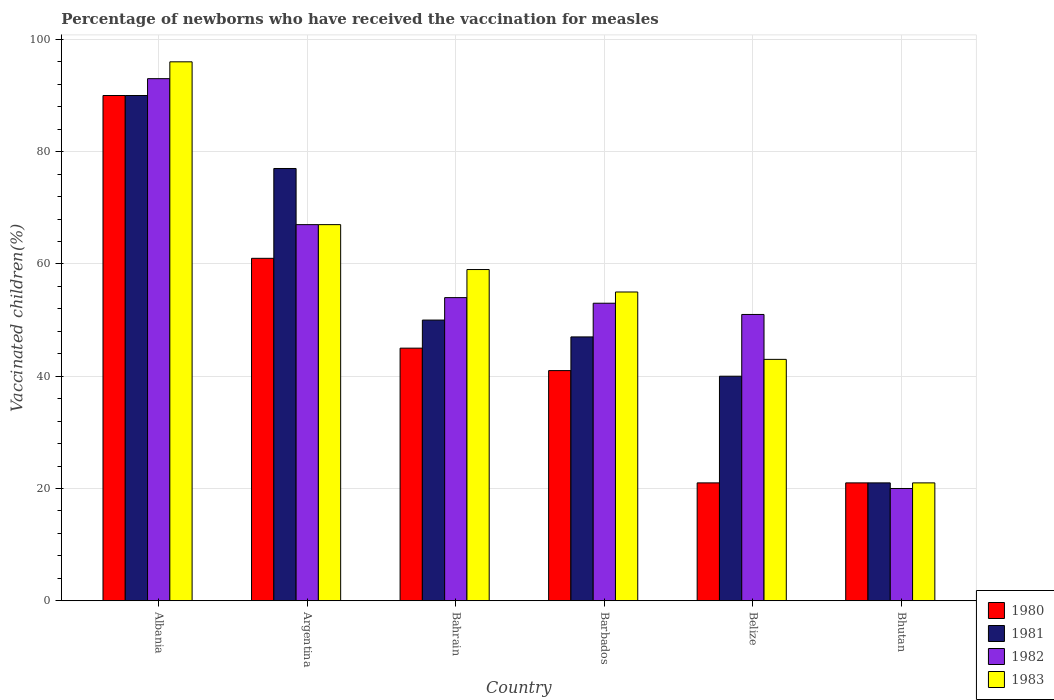Are the number of bars per tick equal to the number of legend labels?
Keep it short and to the point. Yes. What is the label of the 3rd group of bars from the left?
Offer a terse response. Bahrain. In how many cases, is the number of bars for a given country not equal to the number of legend labels?
Offer a terse response. 0. What is the percentage of vaccinated children in 1983 in Albania?
Offer a very short reply. 96. Across all countries, what is the maximum percentage of vaccinated children in 1983?
Make the answer very short. 96. In which country was the percentage of vaccinated children in 1981 maximum?
Provide a succinct answer. Albania. In which country was the percentage of vaccinated children in 1981 minimum?
Offer a terse response. Bhutan. What is the total percentage of vaccinated children in 1982 in the graph?
Your answer should be compact. 338. What is the difference between the percentage of vaccinated children in 1983 in Barbados and that in Belize?
Make the answer very short. 12. What is the average percentage of vaccinated children in 1982 per country?
Provide a short and direct response. 56.33. What is the ratio of the percentage of vaccinated children in 1981 in Argentina to that in Belize?
Your answer should be compact. 1.93. Is the percentage of vaccinated children in 1983 in Albania less than that in Bhutan?
Ensure brevity in your answer.  No. What is the difference between the highest and the lowest percentage of vaccinated children in 1981?
Make the answer very short. 69. Is the sum of the percentage of vaccinated children in 1983 in Albania and Barbados greater than the maximum percentage of vaccinated children in 1980 across all countries?
Your response must be concise. Yes. Is it the case that in every country, the sum of the percentage of vaccinated children in 1981 and percentage of vaccinated children in 1982 is greater than the sum of percentage of vaccinated children in 1983 and percentage of vaccinated children in 1980?
Give a very brief answer. No. Is it the case that in every country, the sum of the percentage of vaccinated children in 1980 and percentage of vaccinated children in 1981 is greater than the percentage of vaccinated children in 1983?
Provide a succinct answer. Yes. How many bars are there?
Your response must be concise. 24. How many countries are there in the graph?
Ensure brevity in your answer.  6. What is the difference between two consecutive major ticks on the Y-axis?
Keep it short and to the point. 20. Does the graph contain any zero values?
Give a very brief answer. No. Does the graph contain grids?
Make the answer very short. Yes. How are the legend labels stacked?
Provide a short and direct response. Vertical. What is the title of the graph?
Your response must be concise. Percentage of newborns who have received the vaccination for measles. What is the label or title of the X-axis?
Your answer should be very brief. Country. What is the label or title of the Y-axis?
Offer a very short reply. Vaccinated children(%). What is the Vaccinated children(%) of 1981 in Albania?
Ensure brevity in your answer.  90. What is the Vaccinated children(%) in 1982 in Albania?
Your response must be concise. 93. What is the Vaccinated children(%) of 1983 in Albania?
Give a very brief answer. 96. What is the Vaccinated children(%) of 1981 in Argentina?
Keep it short and to the point. 77. What is the Vaccinated children(%) of 1983 in Argentina?
Ensure brevity in your answer.  67. What is the Vaccinated children(%) of 1983 in Bahrain?
Give a very brief answer. 59. What is the Vaccinated children(%) in 1980 in Belize?
Your answer should be very brief. 21. What is the Vaccinated children(%) in 1982 in Belize?
Your answer should be compact. 51. What is the Vaccinated children(%) in 1981 in Bhutan?
Provide a short and direct response. 21. Across all countries, what is the maximum Vaccinated children(%) in 1980?
Ensure brevity in your answer.  90. Across all countries, what is the maximum Vaccinated children(%) in 1982?
Make the answer very short. 93. Across all countries, what is the maximum Vaccinated children(%) in 1983?
Your answer should be compact. 96. Across all countries, what is the minimum Vaccinated children(%) in 1981?
Offer a terse response. 21. Across all countries, what is the minimum Vaccinated children(%) of 1983?
Ensure brevity in your answer.  21. What is the total Vaccinated children(%) in 1980 in the graph?
Provide a succinct answer. 279. What is the total Vaccinated children(%) of 1981 in the graph?
Give a very brief answer. 325. What is the total Vaccinated children(%) of 1982 in the graph?
Make the answer very short. 338. What is the total Vaccinated children(%) of 1983 in the graph?
Your answer should be compact. 341. What is the difference between the Vaccinated children(%) in 1981 in Albania and that in Argentina?
Ensure brevity in your answer.  13. What is the difference between the Vaccinated children(%) in 1982 in Albania and that in Argentina?
Your answer should be compact. 26. What is the difference between the Vaccinated children(%) in 1980 in Albania and that in Bahrain?
Provide a short and direct response. 45. What is the difference between the Vaccinated children(%) in 1981 in Albania and that in Bahrain?
Ensure brevity in your answer.  40. What is the difference between the Vaccinated children(%) in 1982 in Albania and that in Bahrain?
Keep it short and to the point. 39. What is the difference between the Vaccinated children(%) in 1980 in Albania and that in Barbados?
Provide a short and direct response. 49. What is the difference between the Vaccinated children(%) in 1982 in Albania and that in Barbados?
Give a very brief answer. 40. What is the difference between the Vaccinated children(%) in 1983 in Albania and that in Barbados?
Ensure brevity in your answer.  41. What is the difference between the Vaccinated children(%) in 1981 in Albania and that in Belize?
Keep it short and to the point. 50. What is the difference between the Vaccinated children(%) in 1983 in Albania and that in Belize?
Ensure brevity in your answer.  53. What is the difference between the Vaccinated children(%) of 1982 in Albania and that in Bhutan?
Provide a succinct answer. 73. What is the difference between the Vaccinated children(%) of 1983 in Albania and that in Bhutan?
Offer a very short reply. 75. What is the difference between the Vaccinated children(%) of 1982 in Argentina and that in Bahrain?
Your response must be concise. 13. What is the difference between the Vaccinated children(%) in 1983 in Argentina and that in Bahrain?
Provide a succinct answer. 8. What is the difference between the Vaccinated children(%) of 1980 in Argentina and that in Barbados?
Offer a very short reply. 20. What is the difference between the Vaccinated children(%) in 1981 in Argentina and that in Barbados?
Offer a terse response. 30. What is the difference between the Vaccinated children(%) in 1980 in Argentina and that in Bhutan?
Ensure brevity in your answer.  40. What is the difference between the Vaccinated children(%) in 1981 in Bahrain and that in Barbados?
Make the answer very short. 3. What is the difference between the Vaccinated children(%) of 1980 in Bahrain and that in Belize?
Your answer should be compact. 24. What is the difference between the Vaccinated children(%) in 1981 in Bahrain and that in Bhutan?
Ensure brevity in your answer.  29. What is the difference between the Vaccinated children(%) in 1981 in Barbados and that in Bhutan?
Your response must be concise. 26. What is the difference between the Vaccinated children(%) in 1983 in Barbados and that in Bhutan?
Your answer should be very brief. 34. What is the difference between the Vaccinated children(%) of 1980 in Belize and that in Bhutan?
Offer a very short reply. 0. What is the difference between the Vaccinated children(%) in 1982 in Belize and that in Bhutan?
Make the answer very short. 31. What is the difference between the Vaccinated children(%) of 1983 in Belize and that in Bhutan?
Keep it short and to the point. 22. What is the difference between the Vaccinated children(%) of 1982 in Albania and the Vaccinated children(%) of 1983 in Argentina?
Provide a succinct answer. 26. What is the difference between the Vaccinated children(%) of 1980 in Albania and the Vaccinated children(%) of 1982 in Bahrain?
Offer a terse response. 36. What is the difference between the Vaccinated children(%) in 1981 in Albania and the Vaccinated children(%) in 1982 in Bahrain?
Make the answer very short. 36. What is the difference between the Vaccinated children(%) in 1981 in Albania and the Vaccinated children(%) in 1983 in Bahrain?
Provide a short and direct response. 31. What is the difference between the Vaccinated children(%) of 1982 in Albania and the Vaccinated children(%) of 1983 in Bahrain?
Provide a succinct answer. 34. What is the difference between the Vaccinated children(%) in 1980 in Albania and the Vaccinated children(%) in 1981 in Barbados?
Your response must be concise. 43. What is the difference between the Vaccinated children(%) in 1980 in Albania and the Vaccinated children(%) in 1982 in Barbados?
Your answer should be compact. 37. What is the difference between the Vaccinated children(%) of 1980 in Albania and the Vaccinated children(%) of 1983 in Barbados?
Offer a very short reply. 35. What is the difference between the Vaccinated children(%) in 1982 in Albania and the Vaccinated children(%) in 1983 in Barbados?
Provide a short and direct response. 38. What is the difference between the Vaccinated children(%) in 1980 in Albania and the Vaccinated children(%) in 1983 in Belize?
Ensure brevity in your answer.  47. What is the difference between the Vaccinated children(%) in 1981 in Albania and the Vaccinated children(%) in 1983 in Belize?
Offer a terse response. 47. What is the difference between the Vaccinated children(%) in 1982 in Albania and the Vaccinated children(%) in 1983 in Belize?
Offer a very short reply. 50. What is the difference between the Vaccinated children(%) in 1980 in Albania and the Vaccinated children(%) in 1981 in Bhutan?
Provide a succinct answer. 69. What is the difference between the Vaccinated children(%) in 1980 in Albania and the Vaccinated children(%) in 1982 in Bhutan?
Offer a terse response. 70. What is the difference between the Vaccinated children(%) of 1982 in Albania and the Vaccinated children(%) of 1983 in Bhutan?
Your answer should be compact. 72. What is the difference between the Vaccinated children(%) in 1980 in Argentina and the Vaccinated children(%) in 1982 in Bahrain?
Offer a very short reply. 7. What is the difference between the Vaccinated children(%) of 1982 in Argentina and the Vaccinated children(%) of 1983 in Bahrain?
Your answer should be compact. 8. What is the difference between the Vaccinated children(%) of 1980 in Argentina and the Vaccinated children(%) of 1981 in Barbados?
Offer a very short reply. 14. What is the difference between the Vaccinated children(%) of 1980 in Argentina and the Vaccinated children(%) of 1982 in Barbados?
Provide a succinct answer. 8. What is the difference between the Vaccinated children(%) of 1980 in Argentina and the Vaccinated children(%) of 1981 in Belize?
Your answer should be compact. 21. What is the difference between the Vaccinated children(%) in 1980 in Argentina and the Vaccinated children(%) in 1982 in Belize?
Make the answer very short. 10. What is the difference between the Vaccinated children(%) in 1981 in Argentina and the Vaccinated children(%) in 1982 in Belize?
Keep it short and to the point. 26. What is the difference between the Vaccinated children(%) in 1980 in Argentina and the Vaccinated children(%) in 1982 in Bhutan?
Provide a succinct answer. 41. What is the difference between the Vaccinated children(%) in 1981 in Bahrain and the Vaccinated children(%) in 1982 in Barbados?
Your response must be concise. -3. What is the difference between the Vaccinated children(%) of 1982 in Bahrain and the Vaccinated children(%) of 1983 in Barbados?
Keep it short and to the point. -1. What is the difference between the Vaccinated children(%) of 1980 in Bahrain and the Vaccinated children(%) of 1981 in Belize?
Offer a terse response. 5. What is the difference between the Vaccinated children(%) of 1980 in Bahrain and the Vaccinated children(%) of 1983 in Belize?
Your answer should be very brief. 2. What is the difference between the Vaccinated children(%) of 1982 in Bahrain and the Vaccinated children(%) of 1983 in Belize?
Your answer should be compact. 11. What is the difference between the Vaccinated children(%) in 1980 in Bahrain and the Vaccinated children(%) in 1982 in Bhutan?
Offer a terse response. 25. What is the difference between the Vaccinated children(%) in 1982 in Bahrain and the Vaccinated children(%) in 1983 in Bhutan?
Keep it short and to the point. 33. What is the difference between the Vaccinated children(%) in 1980 in Barbados and the Vaccinated children(%) in 1981 in Belize?
Keep it short and to the point. 1. What is the difference between the Vaccinated children(%) of 1982 in Barbados and the Vaccinated children(%) of 1983 in Belize?
Provide a short and direct response. 10. What is the difference between the Vaccinated children(%) of 1980 in Barbados and the Vaccinated children(%) of 1981 in Bhutan?
Your response must be concise. 20. What is the difference between the Vaccinated children(%) in 1980 in Barbados and the Vaccinated children(%) in 1982 in Bhutan?
Offer a very short reply. 21. What is the difference between the Vaccinated children(%) of 1981 in Barbados and the Vaccinated children(%) of 1982 in Bhutan?
Give a very brief answer. 27. What is the difference between the Vaccinated children(%) in 1981 in Barbados and the Vaccinated children(%) in 1983 in Bhutan?
Offer a very short reply. 26. What is the difference between the Vaccinated children(%) of 1982 in Barbados and the Vaccinated children(%) of 1983 in Bhutan?
Your answer should be very brief. 32. What is the difference between the Vaccinated children(%) in 1980 in Belize and the Vaccinated children(%) in 1983 in Bhutan?
Make the answer very short. 0. What is the difference between the Vaccinated children(%) in 1981 in Belize and the Vaccinated children(%) in 1983 in Bhutan?
Your answer should be compact. 19. What is the average Vaccinated children(%) in 1980 per country?
Your answer should be very brief. 46.5. What is the average Vaccinated children(%) of 1981 per country?
Your answer should be very brief. 54.17. What is the average Vaccinated children(%) of 1982 per country?
Ensure brevity in your answer.  56.33. What is the average Vaccinated children(%) in 1983 per country?
Provide a succinct answer. 56.83. What is the difference between the Vaccinated children(%) of 1980 and Vaccinated children(%) of 1982 in Albania?
Give a very brief answer. -3. What is the difference between the Vaccinated children(%) in 1981 and Vaccinated children(%) in 1982 in Albania?
Your answer should be compact. -3. What is the difference between the Vaccinated children(%) of 1982 and Vaccinated children(%) of 1983 in Albania?
Ensure brevity in your answer.  -3. What is the difference between the Vaccinated children(%) of 1980 and Vaccinated children(%) of 1983 in Bahrain?
Your response must be concise. -14. What is the difference between the Vaccinated children(%) in 1981 and Vaccinated children(%) in 1982 in Bahrain?
Make the answer very short. -4. What is the difference between the Vaccinated children(%) of 1980 and Vaccinated children(%) of 1981 in Barbados?
Your answer should be very brief. -6. What is the difference between the Vaccinated children(%) of 1980 and Vaccinated children(%) of 1983 in Barbados?
Your answer should be compact. -14. What is the difference between the Vaccinated children(%) of 1981 and Vaccinated children(%) of 1982 in Barbados?
Ensure brevity in your answer.  -6. What is the difference between the Vaccinated children(%) of 1980 and Vaccinated children(%) of 1981 in Belize?
Your answer should be very brief. -19. What is the difference between the Vaccinated children(%) in 1980 and Vaccinated children(%) in 1983 in Belize?
Provide a short and direct response. -22. What is the difference between the Vaccinated children(%) in 1981 and Vaccinated children(%) in 1982 in Belize?
Provide a short and direct response. -11. What is the difference between the Vaccinated children(%) of 1981 and Vaccinated children(%) of 1983 in Belize?
Ensure brevity in your answer.  -3. What is the difference between the Vaccinated children(%) in 1982 and Vaccinated children(%) in 1983 in Belize?
Make the answer very short. 8. What is the difference between the Vaccinated children(%) in 1980 and Vaccinated children(%) in 1981 in Bhutan?
Give a very brief answer. 0. What is the difference between the Vaccinated children(%) of 1981 and Vaccinated children(%) of 1982 in Bhutan?
Ensure brevity in your answer.  1. What is the difference between the Vaccinated children(%) of 1982 and Vaccinated children(%) of 1983 in Bhutan?
Offer a terse response. -1. What is the ratio of the Vaccinated children(%) of 1980 in Albania to that in Argentina?
Your response must be concise. 1.48. What is the ratio of the Vaccinated children(%) in 1981 in Albania to that in Argentina?
Keep it short and to the point. 1.17. What is the ratio of the Vaccinated children(%) of 1982 in Albania to that in Argentina?
Ensure brevity in your answer.  1.39. What is the ratio of the Vaccinated children(%) of 1983 in Albania to that in Argentina?
Your answer should be compact. 1.43. What is the ratio of the Vaccinated children(%) of 1980 in Albania to that in Bahrain?
Make the answer very short. 2. What is the ratio of the Vaccinated children(%) in 1981 in Albania to that in Bahrain?
Provide a succinct answer. 1.8. What is the ratio of the Vaccinated children(%) in 1982 in Albania to that in Bahrain?
Offer a very short reply. 1.72. What is the ratio of the Vaccinated children(%) of 1983 in Albania to that in Bahrain?
Offer a terse response. 1.63. What is the ratio of the Vaccinated children(%) in 1980 in Albania to that in Barbados?
Offer a very short reply. 2.2. What is the ratio of the Vaccinated children(%) in 1981 in Albania to that in Barbados?
Your response must be concise. 1.91. What is the ratio of the Vaccinated children(%) of 1982 in Albania to that in Barbados?
Give a very brief answer. 1.75. What is the ratio of the Vaccinated children(%) in 1983 in Albania to that in Barbados?
Ensure brevity in your answer.  1.75. What is the ratio of the Vaccinated children(%) of 1980 in Albania to that in Belize?
Give a very brief answer. 4.29. What is the ratio of the Vaccinated children(%) in 1981 in Albania to that in Belize?
Offer a terse response. 2.25. What is the ratio of the Vaccinated children(%) of 1982 in Albania to that in Belize?
Make the answer very short. 1.82. What is the ratio of the Vaccinated children(%) in 1983 in Albania to that in Belize?
Your answer should be compact. 2.23. What is the ratio of the Vaccinated children(%) in 1980 in Albania to that in Bhutan?
Your response must be concise. 4.29. What is the ratio of the Vaccinated children(%) in 1981 in Albania to that in Bhutan?
Provide a short and direct response. 4.29. What is the ratio of the Vaccinated children(%) of 1982 in Albania to that in Bhutan?
Offer a very short reply. 4.65. What is the ratio of the Vaccinated children(%) in 1983 in Albania to that in Bhutan?
Give a very brief answer. 4.57. What is the ratio of the Vaccinated children(%) of 1980 in Argentina to that in Bahrain?
Your response must be concise. 1.36. What is the ratio of the Vaccinated children(%) in 1981 in Argentina to that in Bahrain?
Provide a succinct answer. 1.54. What is the ratio of the Vaccinated children(%) of 1982 in Argentina to that in Bahrain?
Offer a very short reply. 1.24. What is the ratio of the Vaccinated children(%) of 1983 in Argentina to that in Bahrain?
Keep it short and to the point. 1.14. What is the ratio of the Vaccinated children(%) of 1980 in Argentina to that in Barbados?
Offer a terse response. 1.49. What is the ratio of the Vaccinated children(%) of 1981 in Argentina to that in Barbados?
Give a very brief answer. 1.64. What is the ratio of the Vaccinated children(%) of 1982 in Argentina to that in Barbados?
Your answer should be compact. 1.26. What is the ratio of the Vaccinated children(%) of 1983 in Argentina to that in Barbados?
Your answer should be compact. 1.22. What is the ratio of the Vaccinated children(%) in 1980 in Argentina to that in Belize?
Provide a succinct answer. 2.9. What is the ratio of the Vaccinated children(%) in 1981 in Argentina to that in Belize?
Ensure brevity in your answer.  1.93. What is the ratio of the Vaccinated children(%) of 1982 in Argentina to that in Belize?
Give a very brief answer. 1.31. What is the ratio of the Vaccinated children(%) in 1983 in Argentina to that in Belize?
Keep it short and to the point. 1.56. What is the ratio of the Vaccinated children(%) of 1980 in Argentina to that in Bhutan?
Your answer should be compact. 2.9. What is the ratio of the Vaccinated children(%) in 1981 in Argentina to that in Bhutan?
Your answer should be compact. 3.67. What is the ratio of the Vaccinated children(%) in 1982 in Argentina to that in Bhutan?
Ensure brevity in your answer.  3.35. What is the ratio of the Vaccinated children(%) of 1983 in Argentina to that in Bhutan?
Your response must be concise. 3.19. What is the ratio of the Vaccinated children(%) in 1980 in Bahrain to that in Barbados?
Offer a terse response. 1.1. What is the ratio of the Vaccinated children(%) in 1981 in Bahrain to that in Barbados?
Provide a succinct answer. 1.06. What is the ratio of the Vaccinated children(%) of 1982 in Bahrain to that in Barbados?
Offer a very short reply. 1.02. What is the ratio of the Vaccinated children(%) in 1983 in Bahrain to that in Barbados?
Your answer should be compact. 1.07. What is the ratio of the Vaccinated children(%) in 1980 in Bahrain to that in Belize?
Provide a short and direct response. 2.14. What is the ratio of the Vaccinated children(%) in 1981 in Bahrain to that in Belize?
Your answer should be very brief. 1.25. What is the ratio of the Vaccinated children(%) of 1982 in Bahrain to that in Belize?
Provide a succinct answer. 1.06. What is the ratio of the Vaccinated children(%) in 1983 in Bahrain to that in Belize?
Your response must be concise. 1.37. What is the ratio of the Vaccinated children(%) in 1980 in Bahrain to that in Bhutan?
Provide a succinct answer. 2.14. What is the ratio of the Vaccinated children(%) of 1981 in Bahrain to that in Bhutan?
Ensure brevity in your answer.  2.38. What is the ratio of the Vaccinated children(%) in 1982 in Bahrain to that in Bhutan?
Keep it short and to the point. 2.7. What is the ratio of the Vaccinated children(%) of 1983 in Bahrain to that in Bhutan?
Your answer should be very brief. 2.81. What is the ratio of the Vaccinated children(%) in 1980 in Barbados to that in Belize?
Keep it short and to the point. 1.95. What is the ratio of the Vaccinated children(%) in 1981 in Barbados to that in Belize?
Offer a terse response. 1.18. What is the ratio of the Vaccinated children(%) of 1982 in Barbados to that in Belize?
Your answer should be very brief. 1.04. What is the ratio of the Vaccinated children(%) of 1983 in Barbados to that in Belize?
Offer a very short reply. 1.28. What is the ratio of the Vaccinated children(%) of 1980 in Barbados to that in Bhutan?
Your answer should be compact. 1.95. What is the ratio of the Vaccinated children(%) in 1981 in Barbados to that in Bhutan?
Give a very brief answer. 2.24. What is the ratio of the Vaccinated children(%) of 1982 in Barbados to that in Bhutan?
Your answer should be very brief. 2.65. What is the ratio of the Vaccinated children(%) of 1983 in Barbados to that in Bhutan?
Provide a succinct answer. 2.62. What is the ratio of the Vaccinated children(%) in 1981 in Belize to that in Bhutan?
Make the answer very short. 1.9. What is the ratio of the Vaccinated children(%) of 1982 in Belize to that in Bhutan?
Provide a short and direct response. 2.55. What is the ratio of the Vaccinated children(%) in 1983 in Belize to that in Bhutan?
Make the answer very short. 2.05. What is the difference between the highest and the second highest Vaccinated children(%) in 1980?
Keep it short and to the point. 29. What is the difference between the highest and the second highest Vaccinated children(%) of 1981?
Keep it short and to the point. 13. What is the difference between the highest and the second highest Vaccinated children(%) in 1982?
Give a very brief answer. 26. What is the difference between the highest and the second highest Vaccinated children(%) in 1983?
Offer a terse response. 29. 